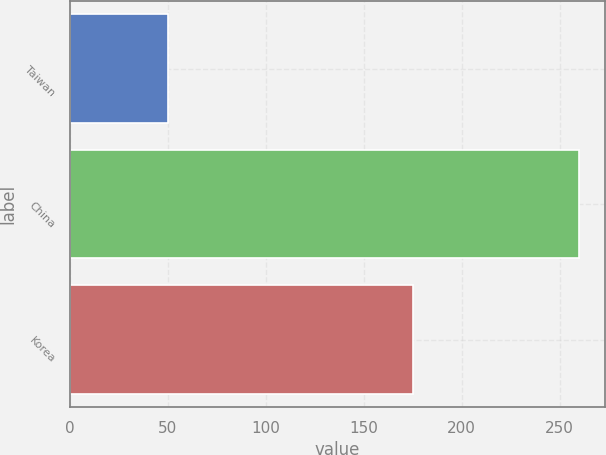<chart> <loc_0><loc_0><loc_500><loc_500><bar_chart><fcel>Taiwan<fcel>China<fcel>Korea<nl><fcel>50<fcel>260<fcel>175<nl></chart> 